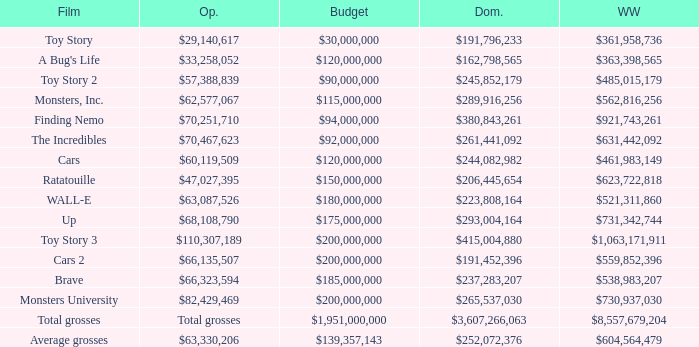Could you parse the entire table as a dict? {'header': ['Film', 'Op.', 'Budget', 'Dom.', 'WW'], 'rows': [['Toy Story', '$29,140,617', '$30,000,000', '$191,796,233', '$361,958,736'], ["A Bug's Life", '$33,258,052', '$120,000,000', '$162,798,565', '$363,398,565'], ['Toy Story 2', '$57,388,839', '$90,000,000', '$245,852,179', '$485,015,179'], ['Monsters, Inc.', '$62,577,067', '$115,000,000', '$289,916,256', '$562,816,256'], ['Finding Nemo', '$70,251,710', '$94,000,000', '$380,843,261', '$921,743,261'], ['The Incredibles', '$70,467,623', '$92,000,000', '$261,441,092', '$631,442,092'], ['Cars', '$60,119,509', '$120,000,000', '$244,082,982', '$461,983,149'], ['Ratatouille', '$47,027,395', '$150,000,000', '$206,445,654', '$623,722,818'], ['WALL-E', '$63,087,526', '$180,000,000', '$223,808,164', '$521,311,860'], ['Up', '$68,108,790', '$175,000,000', '$293,004,164', '$731,342,744'], ['Toy Story 3', '$110,307,189', '$200,000,000', '$415,004,880', '$1,063,171,911'], ['Cars 2', '$66,135,507', '$200,000,000', '$191,452,396', '$559,852,396'], ['Brave', '$66,323,594', '$185,000,000', '$237,283,207', '$538,983,207'], ['Monsters University', '$82,429,469', '$200,000,000', '$265,537,030', '$730,937,030'], ['Total grosses', 'Total grosses', '$1,951,000,000', '$3,607,266,063', '$8,557,679,204'], ['Average grosses', '$63,330,206', '$139,357,143', '$252,072,376', '$604,564,479']]} WHAT IS THE WORLDWIDE BOX OFFICE FOR BRAVE? $538,983,207. 